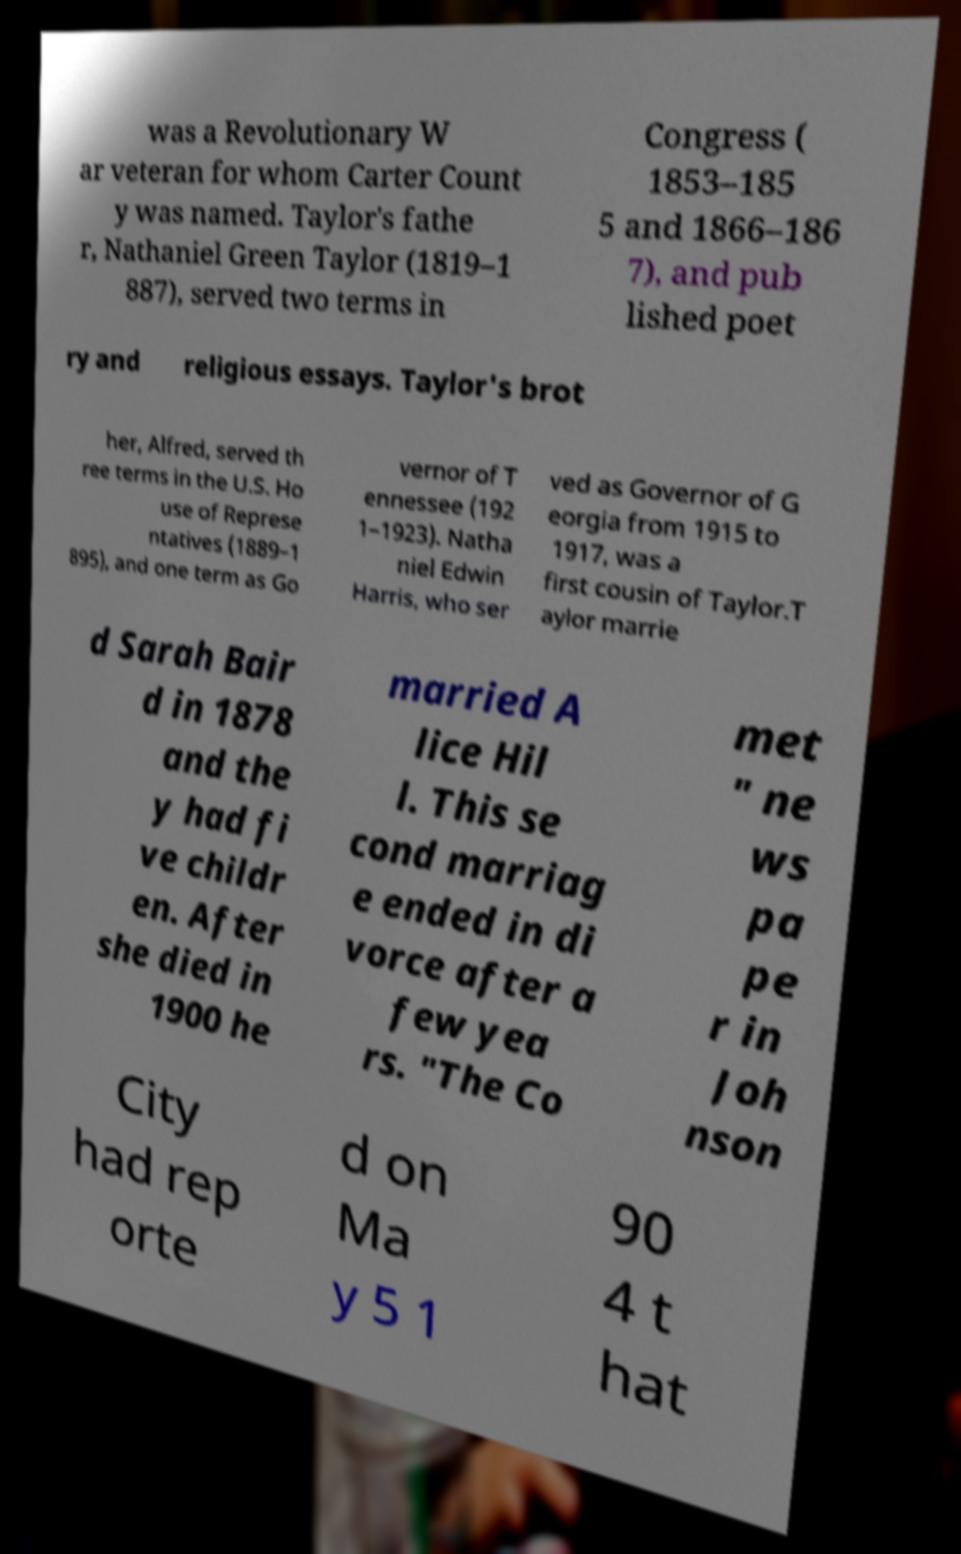Can you accurately transcribe the text from the provided image for me? was a Revolutionary W ar veteran for whom Carter Count y was named. Taylor's fathe r, Nathaniel Green Taylor (1819–1 887), served two terms in Congress ( 1853–185 5 and 1866–186 7), and pub lished poet ry and religious essays. Taylor's brot her, Alfred, served th ree terms in the U.S. Ho use of Represe ntatives (1889–1 895), and one term as Go vernor of T ennessee (192 1–1923). Natha niel Edwin Harris, who ser ved as Governor of G eorgia from 1915 to 1917, was a first cousin of Taylor.T aylor marrie d Sarah Bair d in 1878 and the y had fi ve childr en. After she died in 1900 he married A lice Hil l. This se cond marriag e ended in di vorce after a few yea rs. "The Co met " ne ws pa pe r in Joh nson City had rep orte d on Ma y 5 1 90 4 t hat 